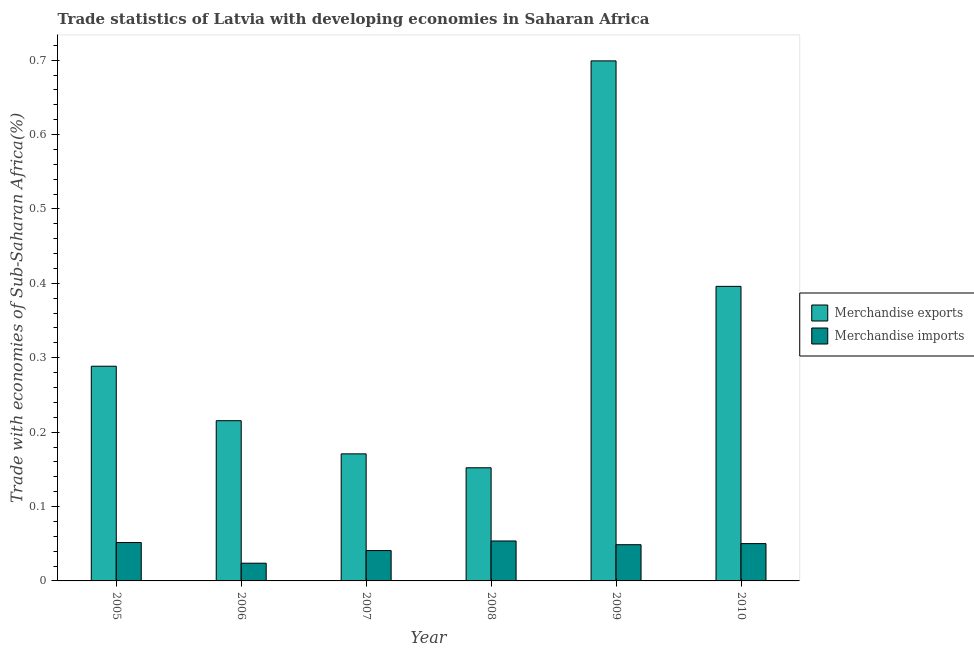How many different coloured bars are there?
Provide a short and direct response. 2. How many groups of bars are there?
Your response must be concise. 6. What is the label of the 2nd group of bars from the left?
Give a very brief answer. 2006. What is the merchandise exports in 2007?
Keep it short and to the point. 0.17. Across all years, what is the maximum merchandise imports?
Give a very brief answer. 0.05. Across all years, what is the minimum merchandise imports?
Offer a terse response. 0.02. What is the total merchandise exports in the graph?
Provide a succinct answer. 1.92. What is the difference between the merchandise exports in 2005 and that in 2006?
Ensure brevity in your answer.  0.07. What is the difference between the merchandise exports in 2008 and the merchandise imports in 2007?
Give a very brief answer. -0.02. What is the average merchandise exports per year?
Your response must be concise. 0.32. In the year 2009, what is the difference between the merchandise exports and merchandise imports?
Give a very brief answer. 0. In how many years, is the merchandise imports greater than 0.16 %?
Ensure brevity in your answer.  0. What is the ratio of the merchandise exports in 2008 to that in 2009?
Keep it short and to the point. 0.22. Is the merchandise exports in 2006 less than that in 2010?
Offer a very short reply. Yes. Is the difference between the merchandise imports in 2006 and 2008 greater than the difference between the merchandise exports in 2006 and 2008?
Your response must be concise. No. What is the difference between the highest and the second highest merchandise imports?
Keep it short and to the point. 0. What is the difference between the highest and the lowest merchandise imports?
Offer a terse response. 0.03. Is the sum of the merchandise imports in 2007 and 2008 greater than the maximum merchandise exports across all years?
Make the answer very short. Yes. What does the 2nd bar from the right in 2006 represents?
Ensure brevity in your answer.  Merchandise exports. How are the legend labels stacked?
Give a very brief answer. Vertical. What is the title of the graph?
Your answer should be compact. Trade statistics of Latvia with developing economies in Saharan Africa. Does "Mineral" appear as one of the legend labels in the graph?
Keep it short and to the point. No. What is the label or title of the Y-axis?
Your answer should be very brief. Trade with economies of Sub-Saharan Africa(%). What is the Trade with economies of Sub-Saharan Africa(%) of Merchandise exports in 2005?
Provide a succinct answer. 0.29. What is the Trade with economies of Sub-Saharan Africa(%) in Merchandise imports in 2005?
Ensure brevity in your answer.  0.05. What is the Trade with economies of Sub-Saharan Africa(%) in Merchandise exports in 2006?
Give a very brief answer. 0.22. What is the Trade with economies of Sub-Saharan Africa(%) in Merchandise imports in 2006?
Ensure brevity in your answer.  0.02. What is the Trade with economies of Sub-Saharan Africa(%) of Merchandise exports in 2007?
Offer a terse response. 0.17. What is the Trade with economies of Sub-Saharan Africa(%) in Merchandise imports in 2007?
Make the answer very short. 0.04. What is the Trade with economies of Sub-Saharan Africa(%) of Merchandise exports in 2008?
Provide a succinct answer. 0.15. What is the Trade with economies of Sub-Saharan Africa(%) of Merchandise imports in 2008?
Your answer should be very brief. 0.05. What is the Trade with economies of Sub-Saharan Africa(%) in Merchandise exports in 2009?
Give a very brief answer. 0.7. What is the Trade with economies of Sub-Saharan Africa(%) in Merchandise imports in 2009?
Provide a short and direct response. 0.05. What is the Trade with economies of Sub-Saharan Africa(%) of Merchandise exports in 2010?
Offer a very short reply. 0.4. What is the Trade with economies of Sub-Saharan Africa(%) of Merchandise imports in 2010?
Offer a very short reply. 0.05. Across all years, what is the maximum Trade with economies of Sub-Saharan Africa(%) of Merchandise exports?
Provide a succinct answer. 0.7. Across all years, what is the maximum Trade with economies of Sub-Saharan Africa(%) of Merchandise imports?
Keep it short and to the point. 0.05. Across all years, what is the minimum Trade with economies of Sub-Saharan Africa(%) of Merchandise exports?
Offer a very short reply. 0.15. Across all years, what is the minimum Trade with economies of Sub-Saharan Africa(%) of Merchandise imports?
Offer a terse response. 0.02. What is the total Trade with economies of Sub-Saharan Africa(%) of Merchandise exports in the graph?
Ensure brevity in your answer.  1.92. What is the total Trade with economies of Sub-Saharan Africa(%) of Merchandise imports in the graph?
Provide a short and direct response. 0.27. What is the difference between the Trade with economies of Sub-Saharan Africa(%) of Merchandise exports in 2005 and that in 2006?
Keep it short and to the point. 0.07. What is the difference between the Trade with economies of Sub-Saharan Africa(%) of Merchandise imports in 2005 and that in 2006?
Your answer should be very brief. 0.03. What is the difference between the Trade with economies of Sub-Saharan Africa(%) in Merchandise exports in 2005 and that in 2007?
Make the answer very short. 0.12. What is the difference between the Trade with economies of Sub-Saharan Africa(%) of Merchandise imports in 2005 and that in 2007?
Offer a very short reply. 0.01. What is the difference between the Trade with economies of Sub-Saharan Africa(%) in Merchandise exports in 2005 and that in 2008?
Your response must be concise. 0.14. What is the difference between the Trade with economies of Sub-Saharan Africa(%) of Merchandise imports in 2005 and that in 2008?
Your answer should be very brief. -0. What is the difference between the Trade with economies of Sub-Saharan Africa(%) in Merchandise exports in 2005 and that in 2009?
Ensure brevity in your answer.  -0.41. What is the difference between the Trade with economies of Sub-Saharan Africa(%) of Merchandise imports in 2005 and that in 2009?
Your answer should be compact. 0. What is the difference between the Trade with economies of Sub-Saharan Africa(%) of Merchandise exports in 2005 and that in 2010?
Your answer should be compact. -0.11. What is the difference between the Trade with economies of Sub-Saharan Africa(%) of Merchandise imports in 2005 and that in 2010?
Make the answer very short. 0. What is the difference between the Trade with economies of Sub-Saharan Africa(%) in Merchandise exports in 2006 and that in 2007?
Offer a very short reply. 0.04. What is the difference between the Trade with economies of Sub-Saharan Africa(%) in Merchandise imports in 2006 and that in 2007?
Provide a succinct answer. -0.02. What is the difference between the Trade with economies of Sub-Saharan Africa(%) of Merchandise exports in 2006 and that in 2008?
Ensure brevity in your answer.  0.06. What is the difference between the Trade with economies of Sub-Saharan Africa(%) in Merchandise imports in 2006 and that in 2008?
Keep it short and to the point. -0.03. What is the difference between the Trade with economies of Sub-Saharan Africa(%) of Merchandise exports in 2006 and that in 2009?
Ensure brevity in your answer.  -0.48. What is the difference between the Trade with economies of Sub-Saharan Africa(%) in Merchandise imports in 2006 and that in 2009?
Give a very brief answer. -0.02. What is the difference between the Trade with economies of Sub-Saharan Africa(%) of Merchandise exports in 2006 and that in 2010?
Your response must be concise. -0.18. What is the difference between the Trade with economies of Sub-Saharan Africa(%) in Merchandise imports in 2006 and that in 2010?
Offer a terse response. -0.03. What is the difference between the Trade with economies of Sub-Saharan Africa(%) in Merchandise exports in 2007 and that in 2008?
Provide a short and direct response. 0.02. What is the difference between the Trade with economies of Sub-Saharan Africa(%) of Merchandise imports in 2007 and that in 2008?
Offer a terse response. -0.01. What is the difference between the Trade with economies of Sub-Saharan Africa(%) of Merchandise exports in 2007 and that in 2009?
Make the answer very short. -0.53. What is the difference between the Trade with economies of Sub-Saharan Africa(%) in Merchandise imports in 2007 and that in 2009?
Keep it short and to the point. -0.01. What is the difference between the Trade with economies of Sub-Saharan Africa(%) in Merchandise exports in 2007 and that in 2010?
Provide a short and direct response. -0.23. What is the difference between the Trade with economies of Sub-Saharan Africa(%) of Merchandise imports in 2007 and that in 2010?
Give a very brief answer. -0.01. What is the difference between the Trade with economies of Sub-Saharan Africa(%) of Merchandise exports in 2008 and that in 2009?
Keep it short and to the point. -0.55. What is the difference between the Trade with economies of Sub-Saharan Africa(%) in Merchandise imports in 2008 and that in 2009?
Offer a very short reply. 0.01. What is the difference between the Trade with economies of Sub-Saharan Africa(%) of Merchandise exports in 2008 and that in 2010?
Ensure brevity in your answer.  -0.24. What is the difference between the Trade with economies of Sub-Saharan Africa(%) in Merchandise imports in 2008 and that in 2010?
Your response must be concise. 0. What is the difference between the Trade with economies of Sub-Saharan Africa(%) in Merchandise exports in 2009 and that in 2010?
Provide a short and direct response. 0.3. What is the difference between the Trade with economies of Sub-Saharan Africa(%) of Merchandise imports in 2009 and that in 2010?
Provide a succinct answer. -0. What is the difference between the Trade with economies of Sub-Saharan Africa(%) in Merchandise exports in 2005 and the Trade with economies of Sub-Saharan Africa(%) in Merchandise imports in 2006?
Your answer should be very brief. 0.26. What is the difference between the Trade with economies of Sub-Saharan Africa(%) in Merchandise exports in 2005 and the Trade with economies of Sub-Saharan Africa(%) in Merchandise imports in 2007?
Your answer should be compact. 0.25. What is the difference between the Trade with economies of Sub-Saharan Africa(%) in Merchandise exports in 2005 and the Trade with economies of Sub-Saharan Africa(%) in Merchandise imports in 2008?
Ensure brevity in your answer.  0.23. What is the difference between the Trade with economies of Sub-Saharan Africa(%) of Merchandise exports in 2005 and the Trade with economies of Sub-Saharan Africa(%) of Merchandise imports in 2009?
Your answer should be compact. 0.24. What is the difference between the Trade with economies of Sub-Saharan Africa(%) of Merchandise exports in 2005 and the Trade with economies of Sub-Saharan Africa(%) of Merchandise imports in 2010?
Your answer should be compact. 0.24. What is the difference between the Trade with economies of Sub-Saharan Africa(%) in Merchandise exports in 2006 and the Trade with economies of Sub-Saharan Africa(%) in Merchandise imports in 2007?
Offer a terse response. 0.17. What is the difference between the Trade with economies of Sub-Saharan Africa(%) in Merchandise exports in 2006 and the Trade with economies of Sub-Saharan Africa(%) in Merchandise imports in 2008?
Keep it short and to the point. 0.16. What is the difference between the Trade with economies of Sub-Saharan Africa(%) in Merchandise exports in 2006 and the Trade with economies of Sub-Saharan Africa(%) in Merchandise imports in 2009?
Make the answer very short. 0.17. What is the difference between the Trade with economies of Sub-Saharan Africa(%) in Merchandise exports in 2006 and the Trade with economies of Sub-Saharan Africa(%) in Merchandise imports in 2010?
Provide a succinct answer. 0.17. What is the difference between the Trade with economies of Sub-Saharan Africa(%) in Merchandise exports in 2007 and the Trade with economies of Sub-Saharan Africa(%) in Merchandise imports in 2008?
Your answer should be very brief. 0.12. What is the difference between the Trade with economies of Sub-Saharan Africa(%) in Merchandise exports in 2007 and the Trade with economies of Sub-Saharan Africa(%) in Merchandise imports in 2009?
Offer a terse response. 0.12. What is the difference between the Trade with economies of Sub-Saharan Africa(%) of Merchandise exports in 2007 and the Trade with economies of Sub-Saharan Africa(%) of Merchandise imports in 2010?
Provide a short and direct response. 0.12. What is the difference between the Trade with economies of Sub-Saharan Africa(%) in Merchandise exports in 2008 and the Trade with economies of Sub-Saharan Africa(%) in Merchandise imports in 2009?
Provide a succinct answer. 0.1. What is the difference between the Trade with economies of Sub-Saharan Africa(%) in Merchandise exports in 2008 and the Trade with economies of Sub-Saharan Africa(%) in Merchandise imports in 2010?
Provide a succinct answer. 0.1. What is the difference between the Trade with economies of Sub-Saharan Africa(%) in Merchandise exports in 2009 and the Trade with economies of Sub-Saharan Africa(%) in Merchandise imports in 2010?
Give a very brief answer. 0.65. What is the average Trade with economies of Sub-Saharan Africa(%) of Merchandise exports per year?
Ensure brevity in your answer.  0.32. What is the average Trade with economies of Sub-Saharan Africa(%) of Merchandise imports per year?
Offer a terse response. 0.04. In the year 2005, what is the difference between the Trade with economies of Sub-Saharan Africa(%) of Merchandise exports and Trade with economies of Sub-Saharan Africa(%) of Merchandise imports?
Offer a terse response. 0.24. In the year 2006, what is the difference between the Trade with economies of Sub-Saharan Africa(%) in Merchandise exports and Trade with economies of Sub-Saharan Africa(%) in Merchandise imports?
Offer a terse response. 0.19. In the year 2007, what is the difference between the Trade with economies of Sub-Saharan Africa(%) in Merchandise exports and Trade with economies of Sub-Saharan Africa(%) in Merchandise imports?
Offer a terse response. 0.13. In the year 2008, what is the difference between the Trade with economies of Sub-Saharan Africa(%) of Merchandise exports and Trade with economies of Sub-Saharan Africa(%) of Merchandise imports?
Provide a short and direct response. 0.1. In the year 2009, what is the difference between the Trade with economies of Sub-Saharan Africa(%) in Merchandise exports and Trade with economies of Sub-Saharan Africa(%) in Merchandise imports?
Provide a short and direct response. 0.65. In the year 2010, what is the difference between the Trade with economies of Sub-Saharan Africa(%) of Merchandise exports and Trade with economies of Sub-Saharan Africa(%) of Merchandise imports?
Offer a terse response. 0.35. What is the ratio of the Trade with economies of Sub-Saharan Africa(%) in Merchandise exports in 2005 to that in 2006?
Your answer should be very brief. 1.34. What is the ratio of the Trade with economies of Sub-Saharan Africa(%) in Merchandise imports in 2005 to that in 2006?
Your answer should be very brief. 2.17. What is the ratio of the Trade with economies of Sub-Saharan Africa(%) of Merchandise exports in 2005 to that in 2007?
Provide a short and direct response. 1.69. What is the ratio of the Trade with economies of Sub-Saharan Africa(%) of Merchandise imports in 2005 to that in 2007?
Your answer should be compact. 1.26. What is the ratio of the Trade with economies of Sub-Saharan Africa(%) of Merchandise exports in 2005 to that in 2008?
Keep it short and to the point. 1.9. What is the ratio of the Trade with economies of Sub-Saharan Africa(%) in Merchandise imports in 2005 to that in 2008?
Your answer should be very brief. 0.96. What is the ratio of the Trade with economies of Sub-Saharan Africa(%) of Merchandise exports in 2005 to that in 2009?
Your answer should be very brief. 0.41. What is the ratio of the Trade with economies of Sub-Saharan Africa(%) in Merchandise imports in 2005 to that in 2009?
Provide a short and direct response. 1.06. What is the ratio of the Trade with economies of Sub-Saharan Africa(%) of Merchandise exports in 2005 to that in 2010?
Your answer should be compact. 0.73. What is the ratio of the Trade with economies of Sub-Saharan Africa(%) in Merchandise imports in 2005 to that in 2010?
Provide a short and direct response. 1.03. What is the ratio of the Trade with economies of Sub-Saharan Africa(%) of Merchandise exports in 2006 to that in 2007?
Your answer should be compact. 1.26. What is the ratio of the Trade with economies of Sub-Saharan Africa(%) of Merchandise imports in 2006 to that in 2007?
Ensure brevity in your answer.  0.58. What is the ratio of the Trade with economies of Sub-Saharan Africa(%) in Merchandise exports in 2006 to that in 2008?
Make the answer very short. 1.42. What is the ratio of the Trade with economies of Sub-Saharan Africa(%) of Merchandise imports in 2006 to that in 2008?
Give a very brief answer. 0.44. What is the ratio of the Trade with economies of Sub-Saharan Africa(%) in Merchandise exports in 2006 to that in 2009?
Ensure brevity in your answer.  0.31. What is the ratio of the Trade with economies of Sub-Saharan Africa(%) in Merchandise imports in 2006 to that in 2009?
Offer a terse response. 0.49. What is the ratio of the Trade with economies of Sub-Saharan Africa(%) in Merchandise exports in 2006 to that in 2010?
Provide a short and direct response. 0.54. What is the ratio of the Trade with economies of Sub-Saharan Africa(%) of Merchandise imports in 2006 to that in 2010?
Ensure brevity in your answer.  0.48. What is the ratio of the Trade with economies of Sub-Saharan Africa(%) of Merchandise exports in 2007 to that in 2008?
Your answer should be very brief. 1.12. What is the ratio of the Trade with economies of Sub-Saharan Africa(%) of Merchandise imports in 2007 to that in 2008?
Your answer should be compact. 0.76. What is the ratio of the Trade with economies of Sub-Saharan Africa(%) in Merchandise exports in 2007 to that in 2009?
Keep it short and to the point. 0.24. What is the ratio of the Trade with economies of Sub-Saharan Africa(%) of Merchandise imports in 2007 to that in 2009?
Provide a short and direct response. 0.84. What is the ratio of the Trade with economies of Sub-Saharan Africa(%) in Merchandise exports in 2007 to that in 2010?
Give a very brief answer. 0.43. What is the ratio of the Trade with economies of Sub-Saharan Africa(%) in Merchandise imports in 2007 to that in 2010?
Give a very brief answer. 0.81. What is the ratio of the Trade with economies of Sub-Saharan Africa(%) in Merchandise exports in 2008 to that in 2009?
Ensure brevity in your answer.  0.22. What is the ratio of the Trade with economies of Sub-Saharan Africa(%) of Merchandise imports in 2008 to that in 2009?
Provide a succinct answer. 1.1. What is the ratio of the Trade with economies of Sub-Saharan Africa(%) of Merchandise exports in 2008 to that in 2010?
Provide a succinct answer. 0.38. What is the ratio of the Trade with economies of Sub-Saharan Africa(%) in Merchandise imports in 2008 to that in 2010?
Your answer should be very brief. 1.07. What is the ratio of the Trade with economies of Sub-Saharan Africa(%) in Merchandise exports in 2009 to that in 2010?
Provide a short and direct response. 1.77. What is the ratio of the Trade with economies of Sub-Saharan Africa(%) in Merchandise imports in 2009 to that in 2010?
Offer a terse response. 0.97. What is the difference between the highest and the second highest Trade with economies of Sub-Saharan Africa(%) of Merchandise exports?
Your answer should be compact. 0.3. What is the difference between the highest and the second highest Trade with economies of Sub-Saharan Africa(%) of Merchandise imports?
Make the answer very short. 0. What is the difference between the highest and the lowest Trade with economies of Sub-Saharan Africa(%) in Merchandise exports?
Your response must be concise. 0.55. What is the difference between the highest and the lowest Trade with economies of Sub-Saharan Africa(%) in Merchandise imports?
Give a very brief answer. 0.03. 